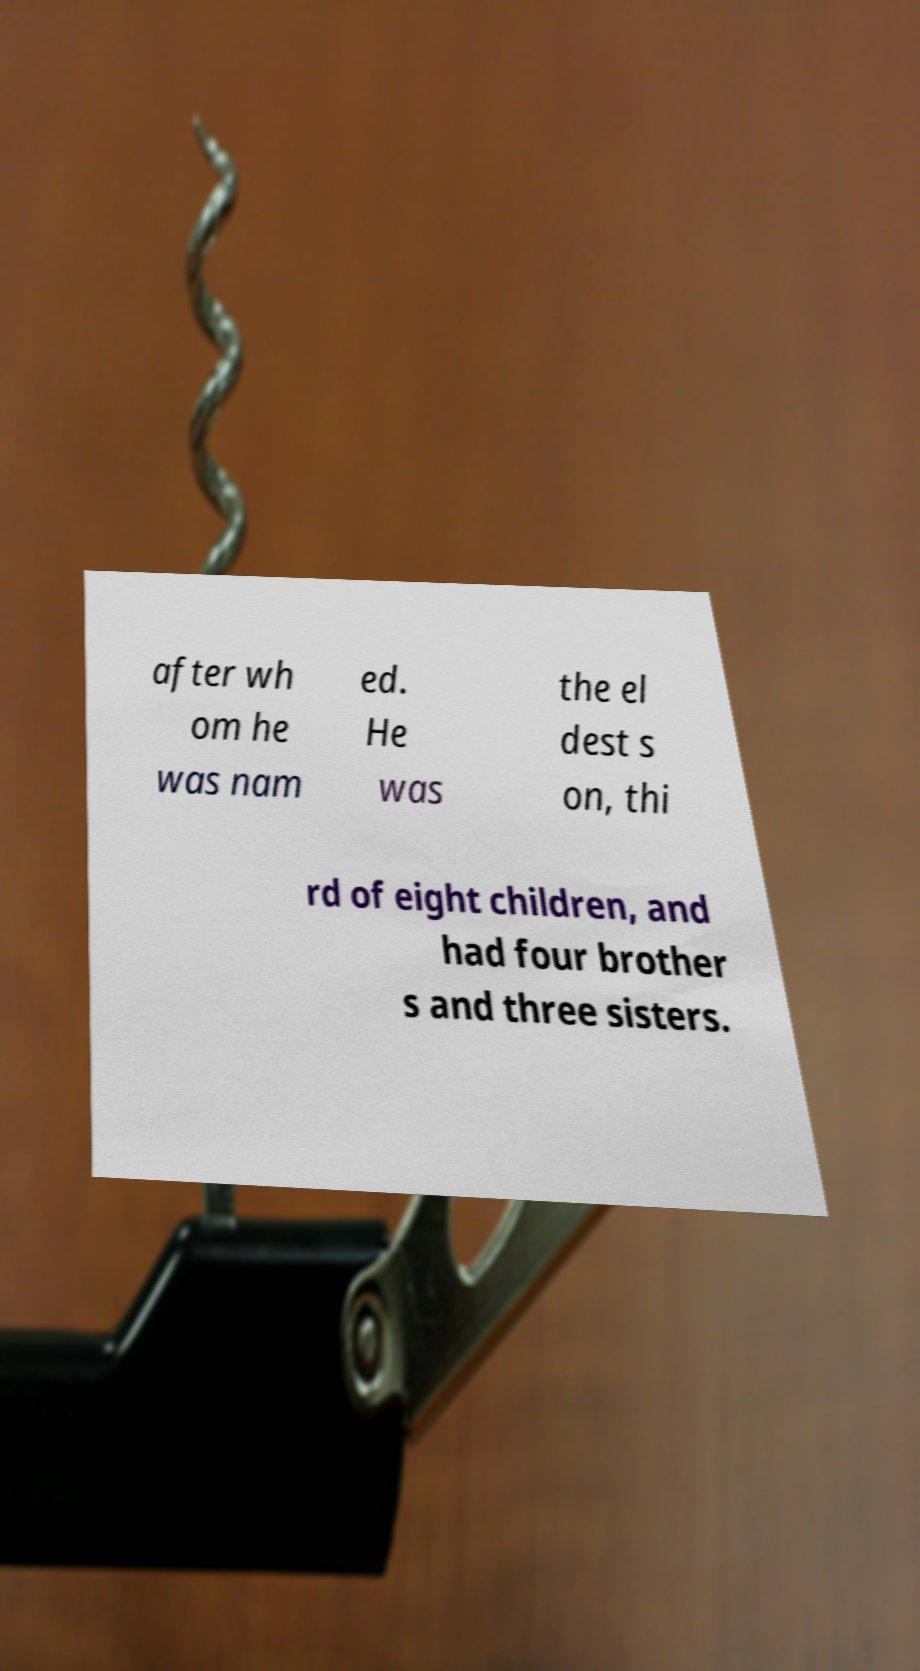Can you read and provide the text displayed in the image?This photo seems to have some interesting text. Can you extract and type it out for me? after wh om he was nam ed. He was the el dest s on, thi rd of eight children, and had four brother s and three sisters. 